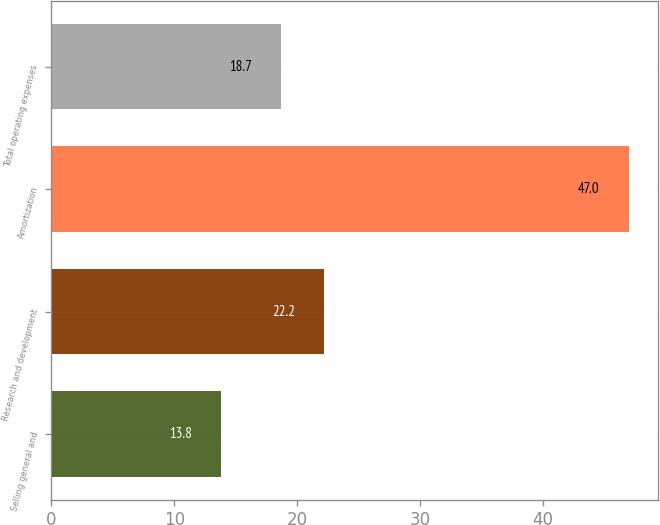<chart> <loc_0><loc_0><loc_500><loc_500><bar_chart><fcel>Selling general and<fcel>Research and development<fcel>Amortization<fcel>Total operating expenses<nl><fcel>13.8<fcel>22.2<fcel>47<fcel>18.7<nl></chart> 